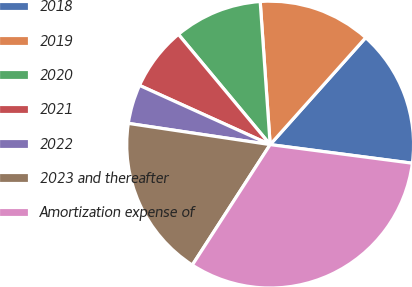Convert chart. <chart><loc_0><loc_0><loc_500><loc_500><pie_chart><fcel>2018<fcel>2019<fcel>2020<fcel>2021<fcel>2022<fcel>2023 and thereafter<fcel>Amortization expense of<nl><fcel>15.47%<fcel>12.71%<fcel>9.94%<fcel>7.18%<fcel>4.41%<fcel>18.23%<fcel>32.06%<nl></chart> 